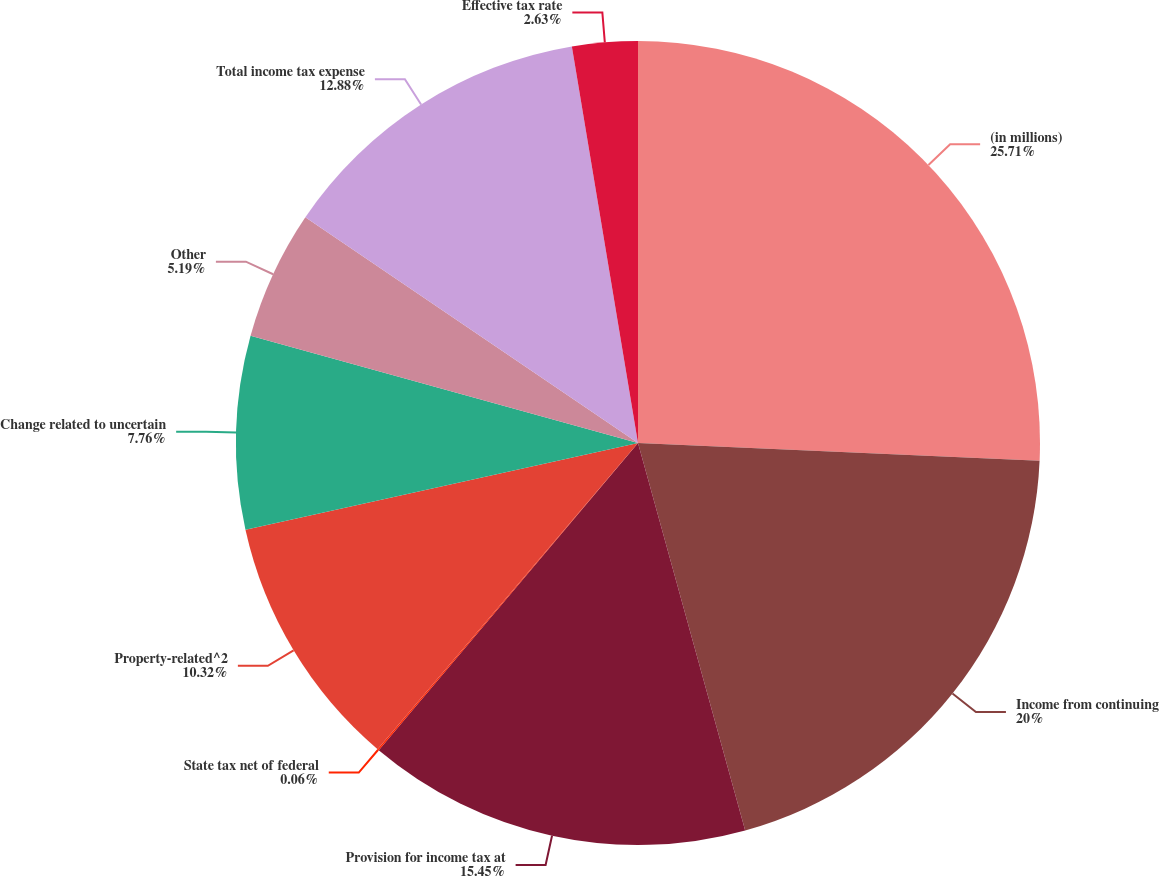<chart> <loc_0><loc_0><loc_500><loc_500><pie_chart><fcel>(in millions)<fcel>Income from continuing<fcel>Provision for income tax at<fcel>State tax net of federal<fcel>Property-related^2<fcel>Change related to uncertain<fcel>Other<fcel>Total income tax expense<fcel>Effective tax rate<nl><fcel>25.7%<fcel>20.0%<fcel>15.45%<fcel>0.06%<fcel>10.32%<fcel>7.76%<fcel>5.19%<fcel>12.88%<fcel>2.63%<nl></chart> 